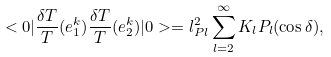<formula> <loc_0><loc_0><loc_500><loc_500>< 0 | \frac { \delta T } { T } ( e _ { 1 } ^ { k } ) \frac { \delta T } { T } ( e ^ { k } _ { 2 } ) | 0 > = l _ { P l } ^ { 2 } \sum _ { l = 2 } ^ { \infty } K _ { l } P _ { l } ( \cos \delta ) ,</formula> 